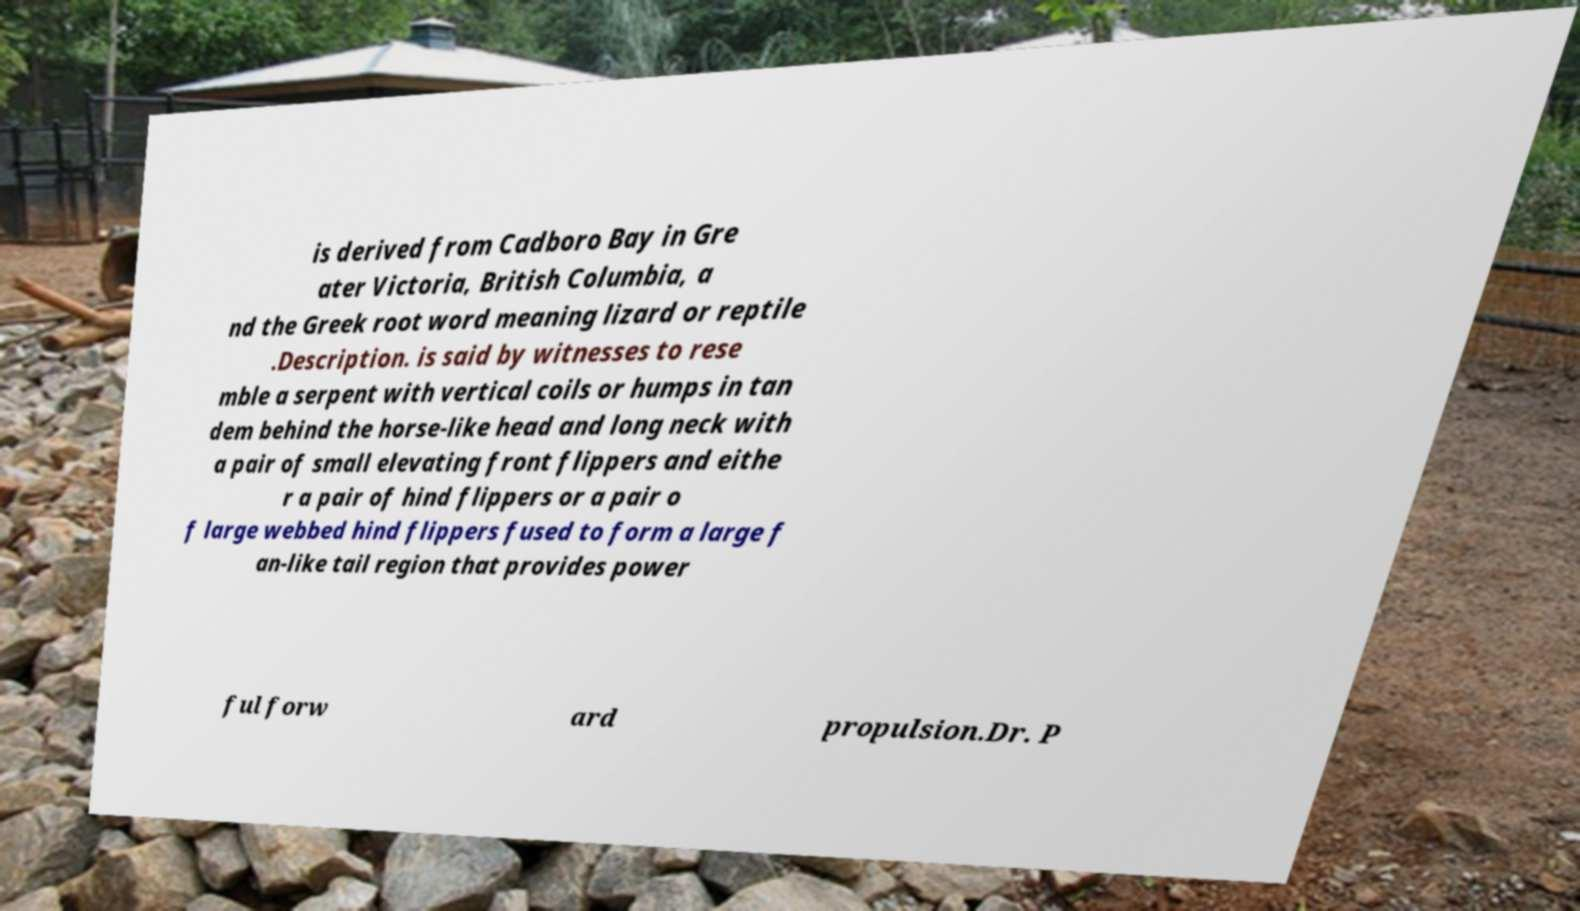For documentation purposes, I need the text within this image transcribed. Could you provide that? is derived from Cadboro Bay in Gre ater Victoria, British Columbia, a nd the Greek root word meaning lizard or reptile .Description. is said by witnesses to rese mble a serpent with vertical coils or humps in tan dem behind the horse-like head and long neck with a pair of small elevating front flippers and eithe r a pair of hind flippers or a pair o f large webbed hind flippers fused to form a large f an-like tail region that provides power ful forw ard propulsion.Dr. P 